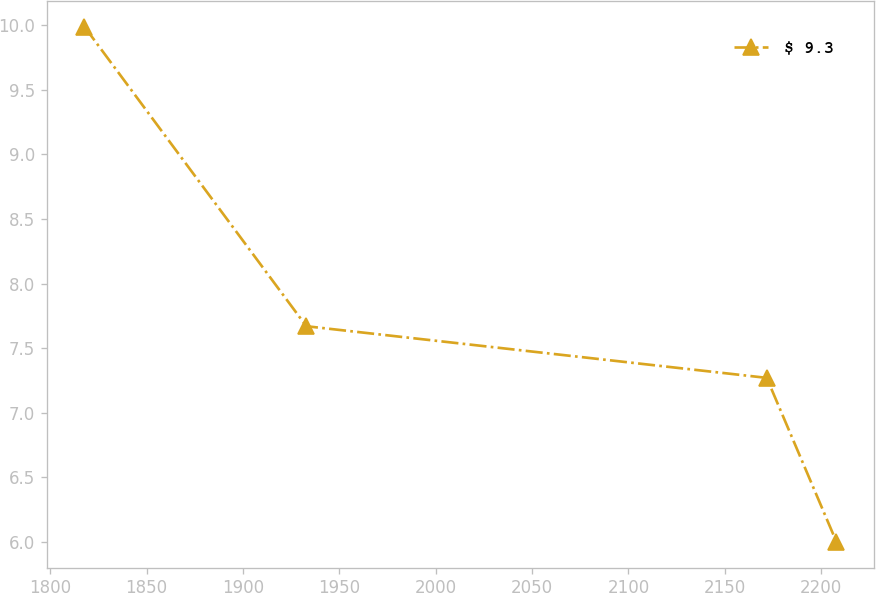Convert chart. <chart><loc_0><loc_0><loc_500><loc_500><line_chart><ecel><fcel>$ 9.3<nl><fcel>1817.74<fcel>9.99<nl><fcel>1932.92<fcel>7.67<nl><fcel>2171.77<fcel>7.27<nl><fcel>2207.95<fcel>6<nl></chart> 